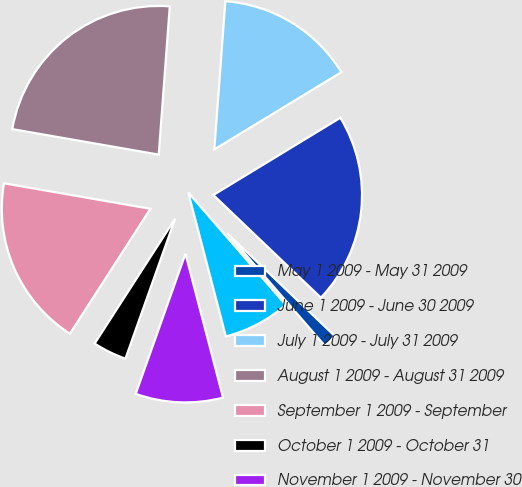<chart> <loc_0><loc_0><loc_500><loc_500><pie_chart><fcel>May 1 2009 - May 31 2009<fcel>June 1 2009 - June 30 2009<fcel>July 1 2009 - July 31 2009<fcel>August 1 2009 - August 31 2009<fcel>September 1 2009 - September<fcel>October 1 2009 - October 31<fcel>November 1 2009 - November 30<fcel>December 1 2009 - December 31<nl><fcel>1.49%<fcel>20.83%<fcel>15.12%<fcel>23.44%<fcel>18.63%<fcel>3.68%<fcel>9.5%<fcel>7.31%<nl></chart> 